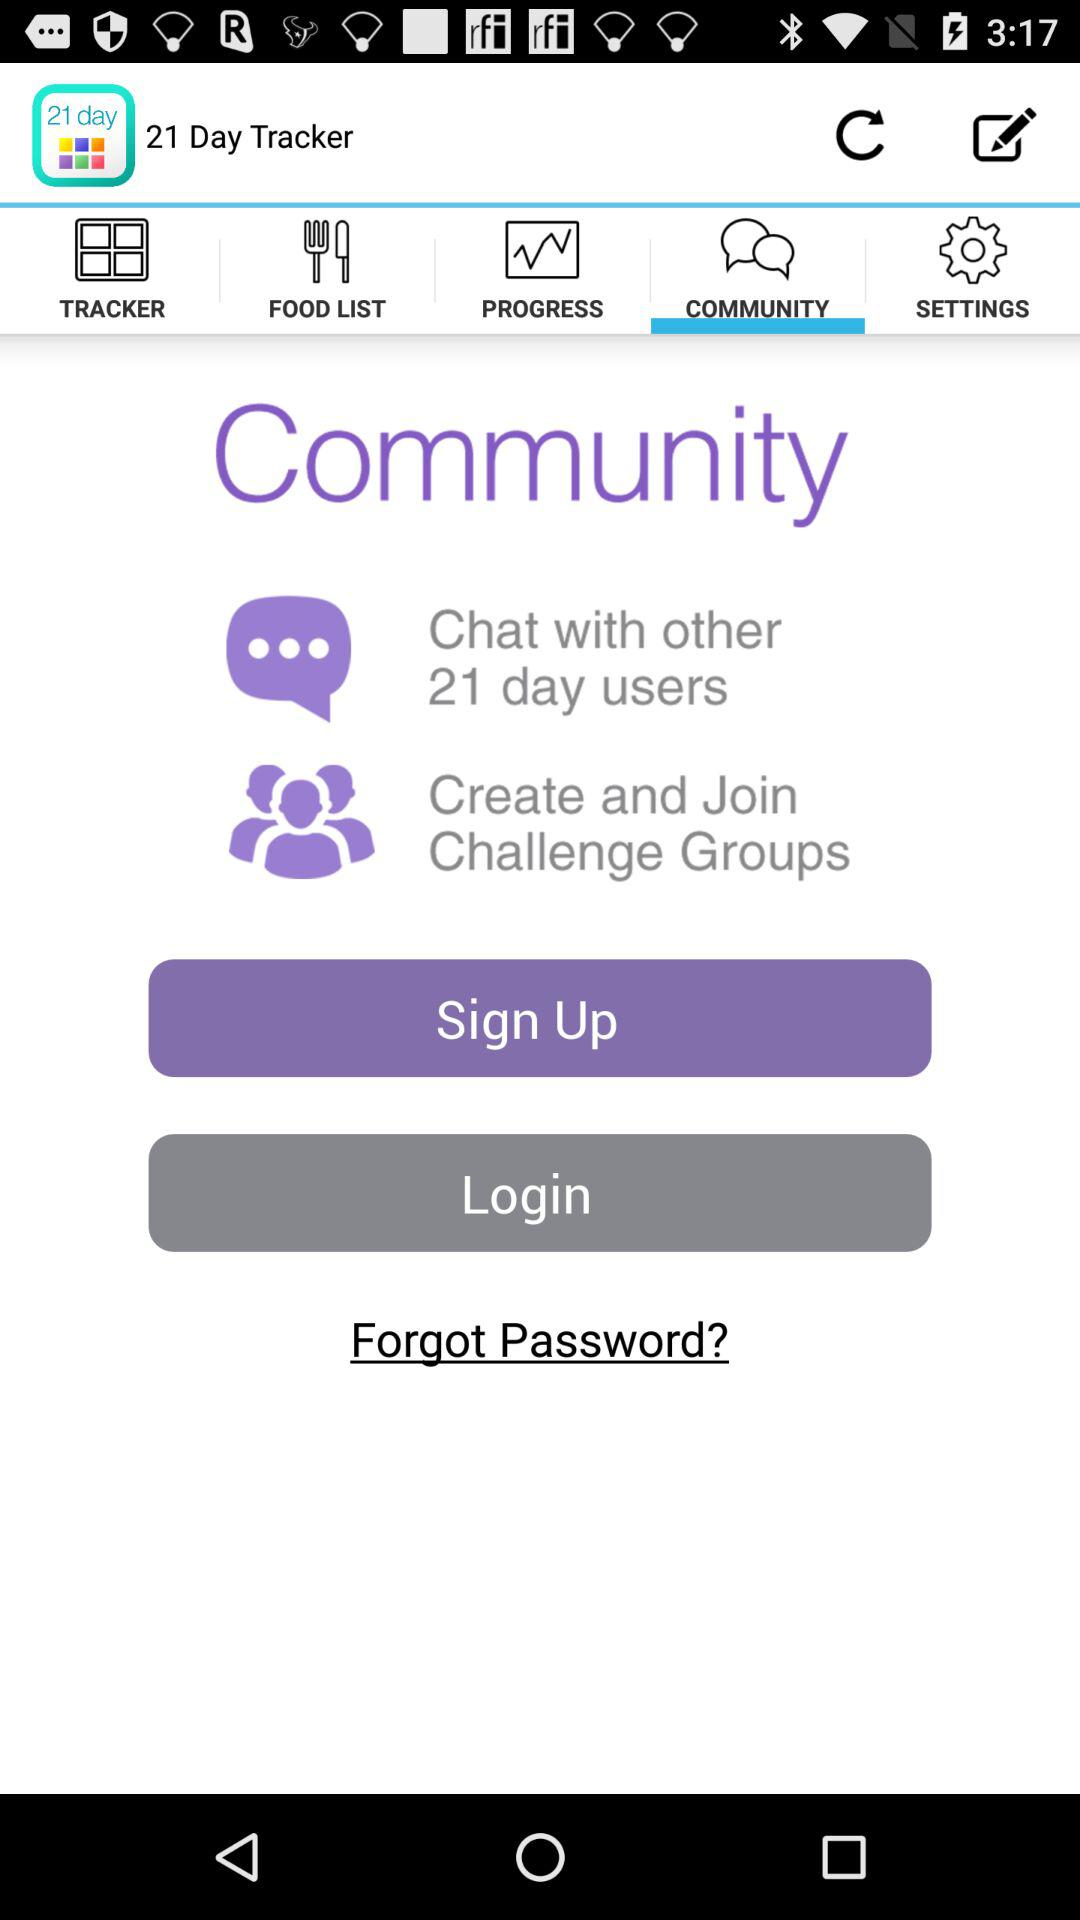What is the name of the application? The name of the application is "21 Day Tracker". 